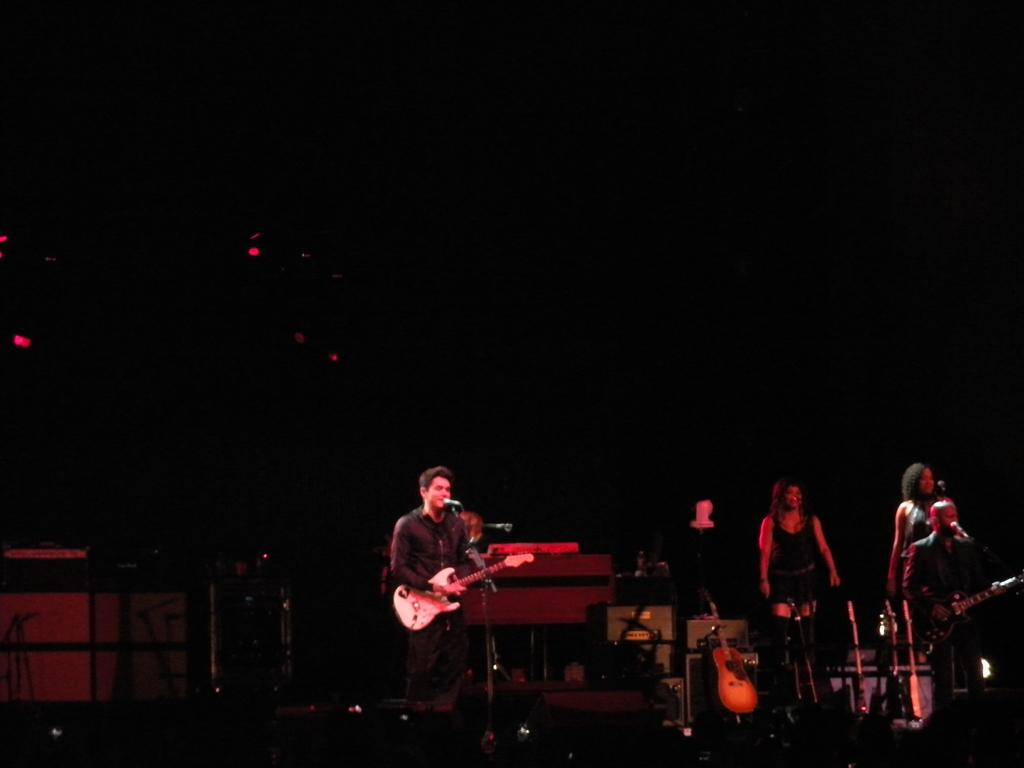What is happening in the image? There is a group of people in the image, and they are on a stage. What are the people doing on the stage? The people are holding musical instruments and playing them. What type of leaf is being used as a stocking for the ink in the image? There is no leaf, stocking, or ink present in the image. The image features a group of people playing musical instruments on a stage. 